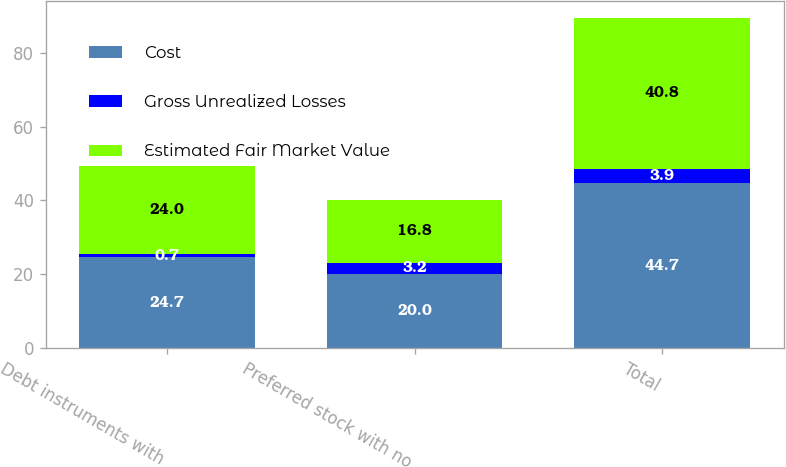Convert chart to OTSL. <chart><loc_0><loc_0><loc_500><loc_500><stacked_bar_chart><ecel><fcel>Debt instruments with<fcel>Preferred stock with no<fcel>Total<nl><fcel>Cost<fcel>24.7<fcel>20<fcel>44.7<nl><fcel>Gross Unrealized Losses<fcel>0.7<fcel>3.2<fcel>3.9<nl><fcel>Estimated Fair Market Value<fcel>24<fcel>16.8<fcel>40.8<nl></chart> 